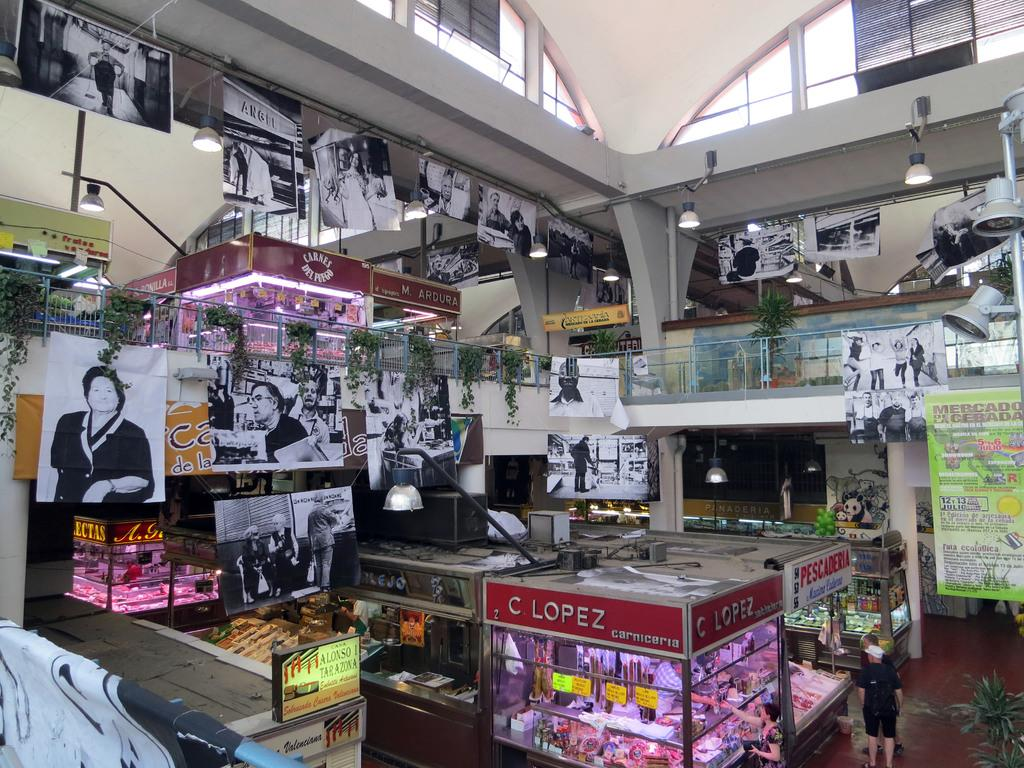What type of structure can be seen in the image? There is a wall in the image. What is another barrier visible in the image? There is a fence in the image. What type of vegetation is present in the image? There are plants in the image. What type of decorations are visible in the image? There are banners in the image. What type of display device is present in the image? There is a screen in the image. Are there any people in the image? Yes, there are people in the image. What type of artistic features can be seen in the image? There are statues in the image. What type of illumination is present in the image? There are lights in the image. What type of sand can be seen in the image? There is no sand present in the image. Can you describe the stranger in the image? There is no stranger present in the image. What type of cord is used to connect the lights in the image? There is no cord visible in the image; the lights are not connected in a way that requires a cord. 